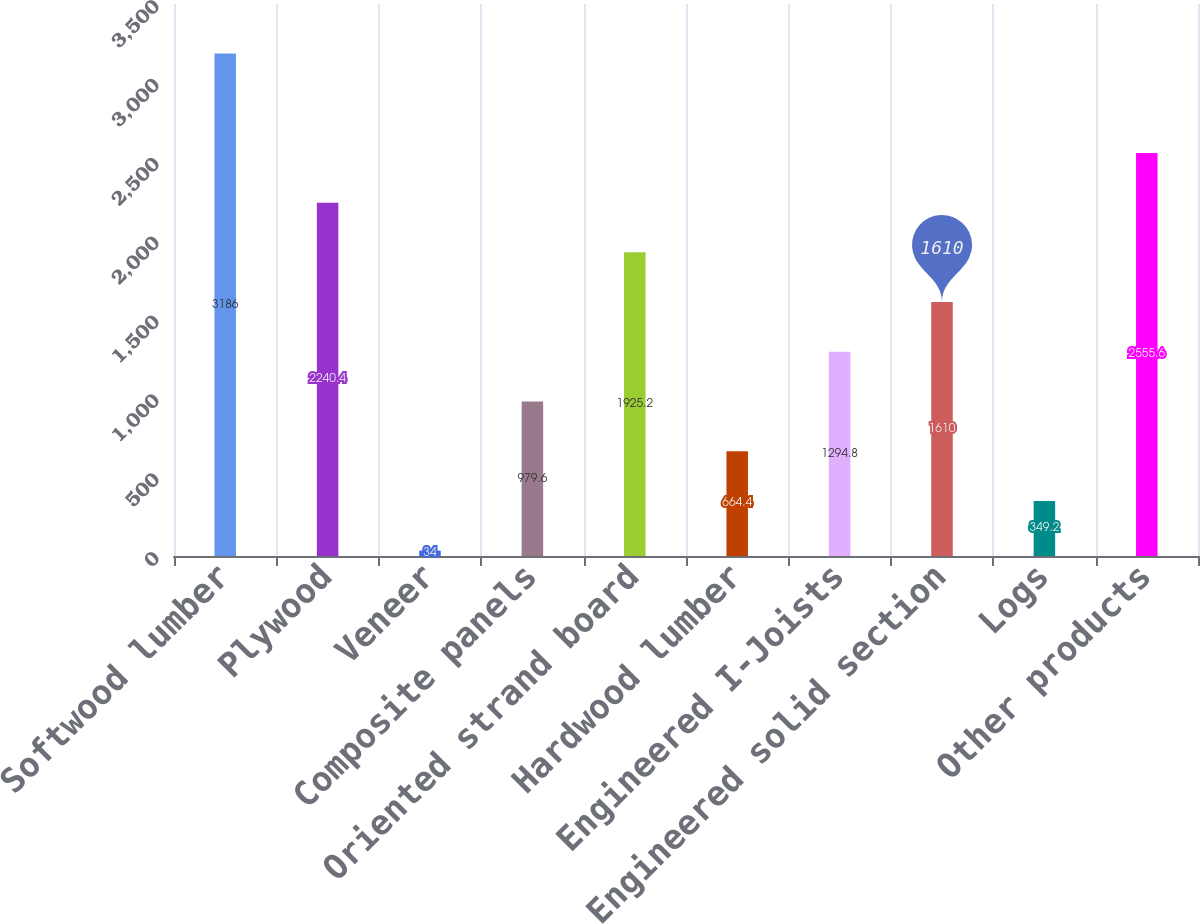Convert chart. <chart><loc_0><loc_0><loc_500><loc_500><bar_chart><fcel>Softwood lumber<fcel>Plywood<fcel>Veneer<fcel>Composite panels<fcel>Oriented strand board<fcel>Hardwood lumber<fcel>Engineered I-Joists<fcel>Engineered solid section<fcel>Logs<fcel>Other products<nl><fcel>3186<fcel>2240.4<fcel>34<fcel>979.6<fcel>1925.2<fcel>664.4<fcel>1294.8<fcel>1610<fcel>349.2<fcel>2555.6<nl></chart> 